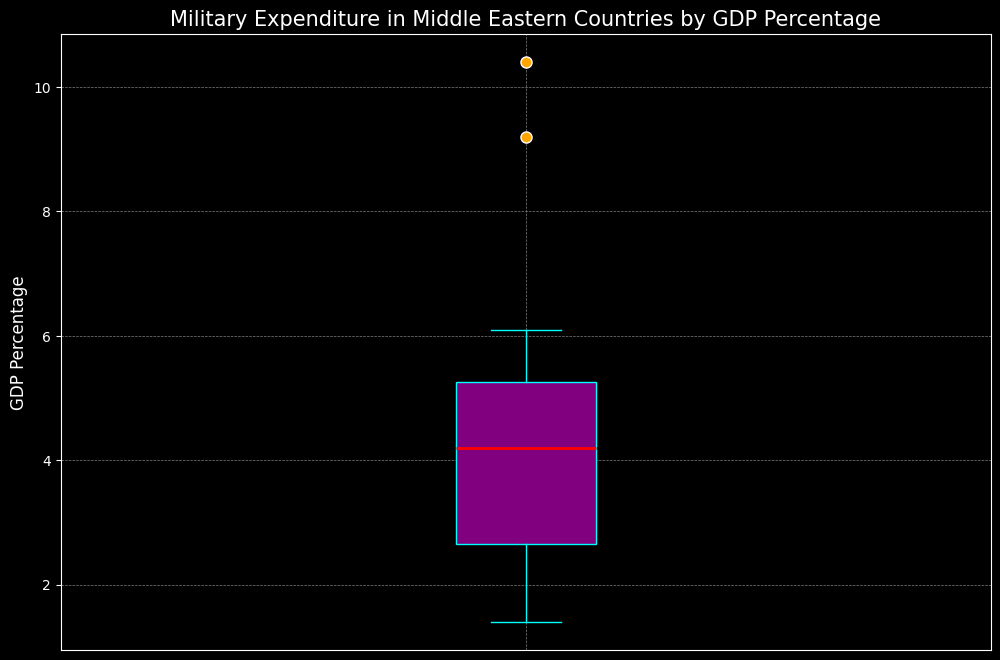What is the median value of military expenditure as a percentage of GDP in Middle Eastern countries? The median value is typically shown as a red line within the box in the box plot. Identify this red line.
Answer: 4.5 Which country's military expenditure as a percentage of GDP is represented by the highest outlier? Outliers are represented by orange markers; the highest marker represents the highest outlier.
Answer: Saudi Arabia What is the range of the military expenditure percentages depicted in the plot? The range is the difference between the maximum and minimum values. Identify the top of the highest whisker and the bottom of the lowest whisker.
Answer: 1.4 to 10.4 Which country has a military expenditure just below the median value? The median value is a red line in the box plot. Identify the country just below this line.
Answer: Jordan How does the interquartile range (IQR) appear visually on the plot? The IQR is the height of the box, which visually represents the range between the first quartile (Q1) and third quartile (Q3). Identify the box's height.
Answer: Between ~2.5 and ~5.5 Which country has the closest military expenditure to the first quartile (Q1)? The first quartile is the bottom edge of the box. Identify the country closest to this value.
Answer: Tunisia Are there more countries with military expenditure as a percentage of GDP above the median or below it? Observe the number of data points (countries) visibly falling above and below the red median line.
Answer: Above By how much does the military expenditure of Saudi Arabia exceed the median value? Subtract the median value (red line) from Saudi Arabia’s value (highest outlier).
Answer: 5.9 Is the military expenditure of Egypt above or below the first quartile (Q1)? Compare Egypt’s value to the bottom edge of the box (first quartile).
Answer: Below 